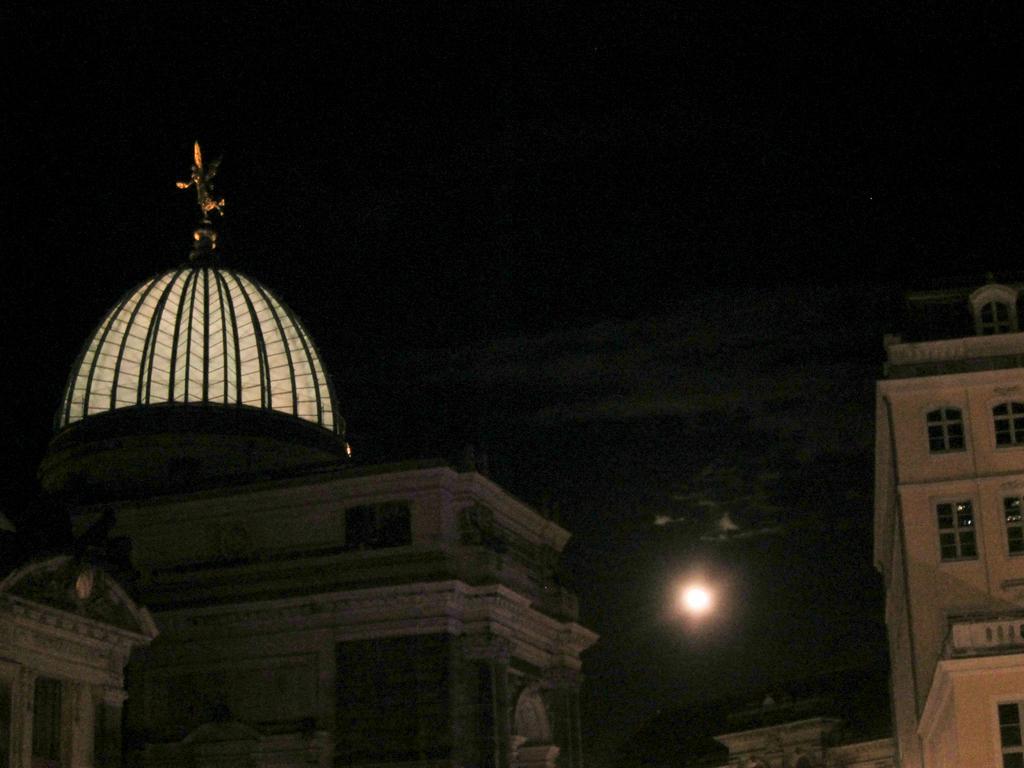Could you give a brief overview of what you see in this image? In this image I can see some buildings I can see a statue with some light at the top of the building on the left hand side. I can see the moon. I can see the sky at the top of the image. The background is dark. 